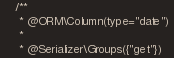Convert code to text. <code><loc_0><loc_0><loc_500><loc_500><_PHP_>    /** 
     * @ORM\Column(type="date") 
     * 
     * @Serializer\Groups({"get"})</code> 